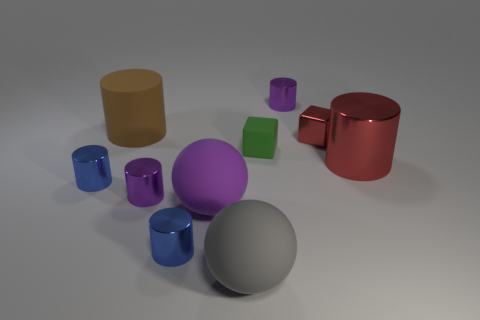Subtract 2 cylinders. How many cylinders are left? 4 Subtract all brown cylinders. How many cylinders are left? 5 Subtract all purple metallic cylinders. How many cylinders are left? 4 Subtract all red cylinders. Subtract all green cubes. How many cylinders are left? 5 Subtract all cylinders. How many objects are left? 4 Add 6 big balls. How many big balls are left? 8 Add 3 big brown matte balls. How many big brown matte balls exist? 3 Subtract 2 purple cylinders. How many objects are left? 8 Subtract all small metallic balls. Subtract all purple metal cylinders. How many objects are left? 8 